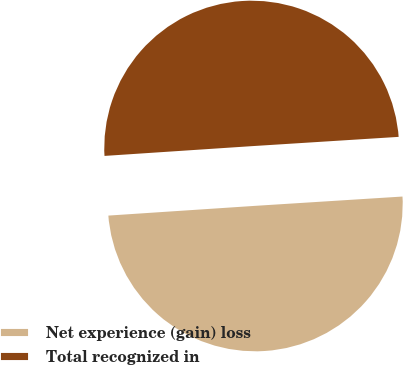Convert chart. <chart><loc_0><loc_0><loc_500><loc_500><pie_chart><fcel>Net experience (gain) loss<fcel>Total recognized in<nl><fcel>49.95%<fcel>50.05%<nl></chart> 